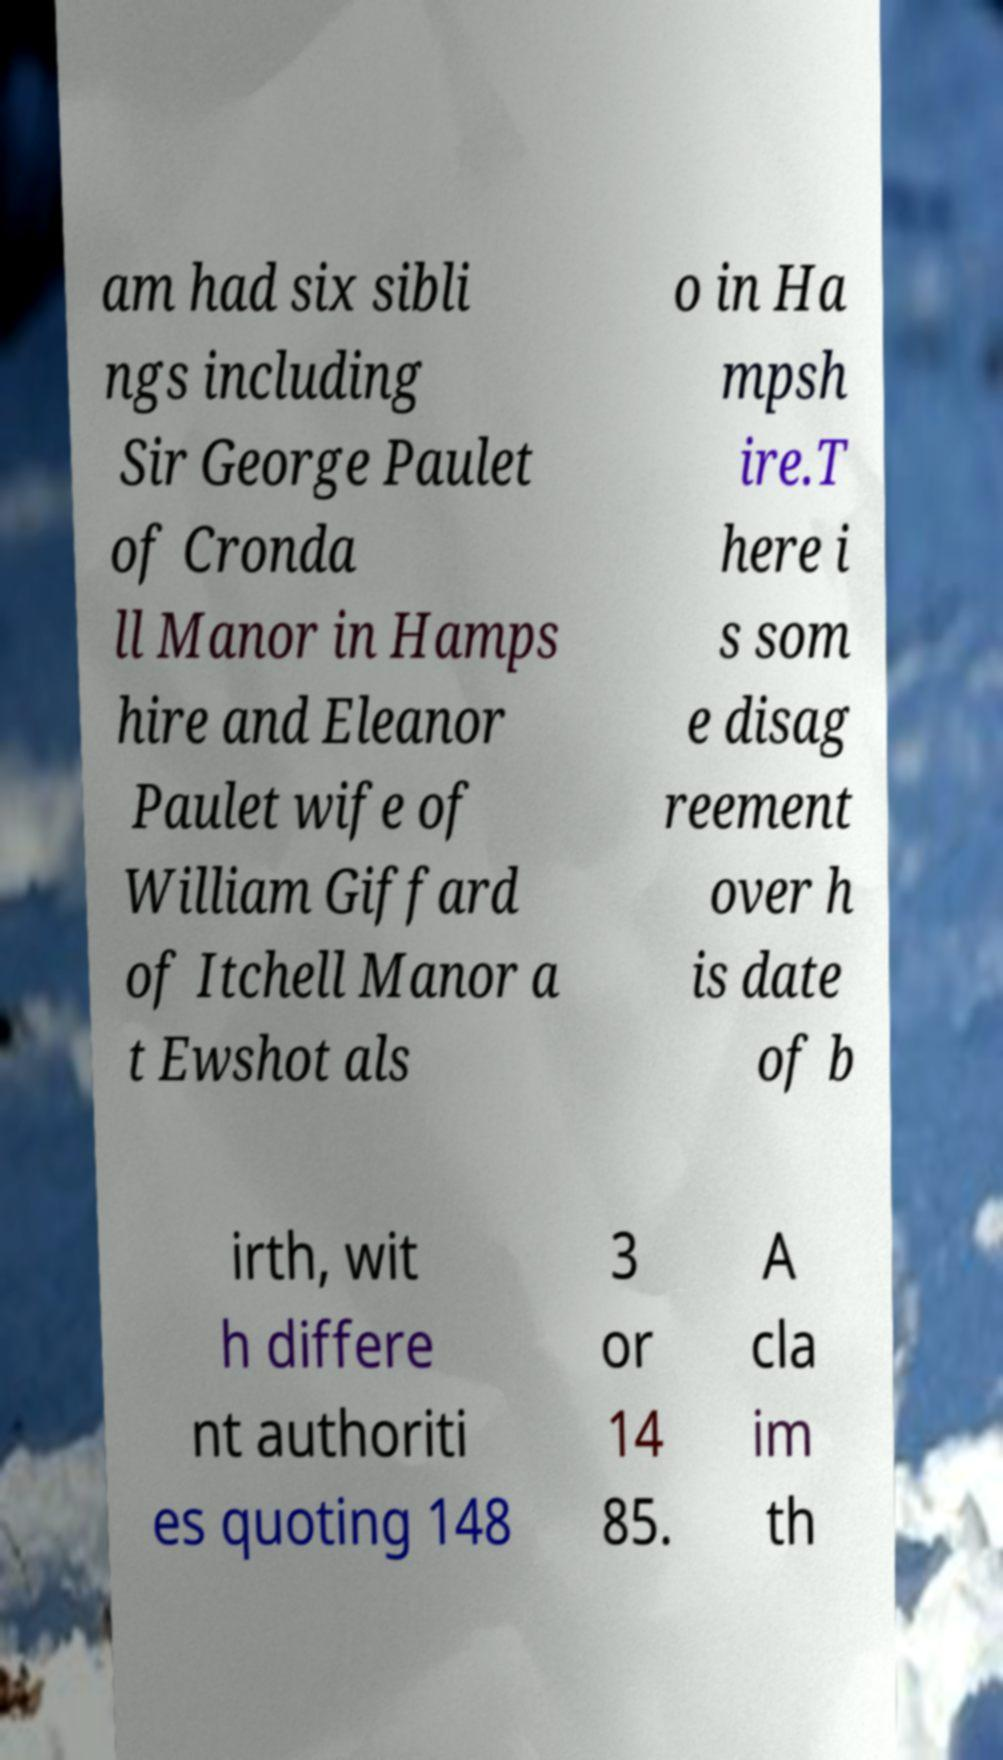What messages or text are displayed in this image? I need them in a readable, typed format. am had six sibli ngs including Sir George Paulet of Cronda ll Manor in Hamps hire and Eleanor Paulet wife of William Giffard of Itchell Manor a t Ewshot als o in Ha mpsh ire.T here i s som e disag reement over h is date of b irth, wit h differe nt authoriti es quoting 148 3 or 14 85. A cla im th 